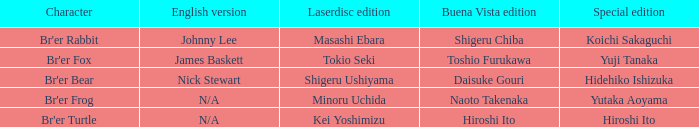Who is the buena vista edition where exclusive edition is koichi sakaguchi? Shigeru Chiba. 